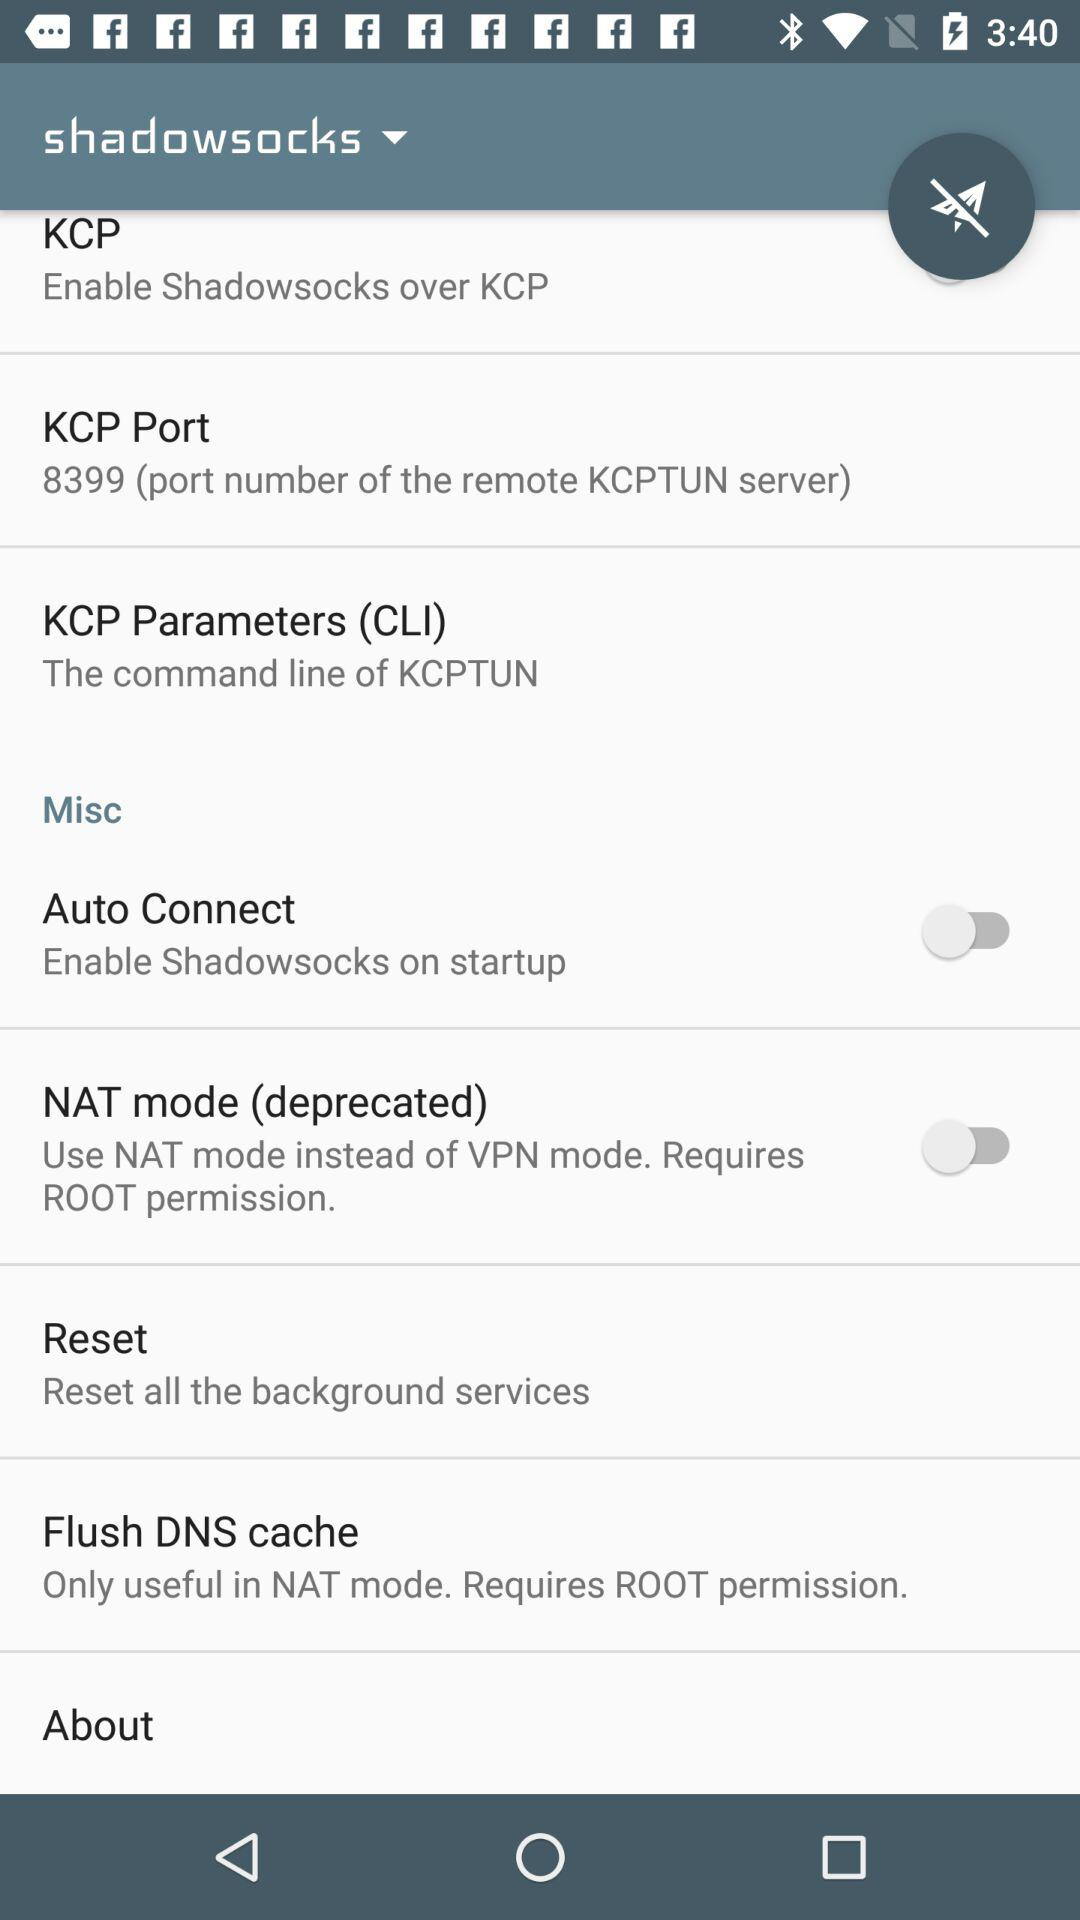How many items have a switch?
Answer the question using a single word or phrase. 2 